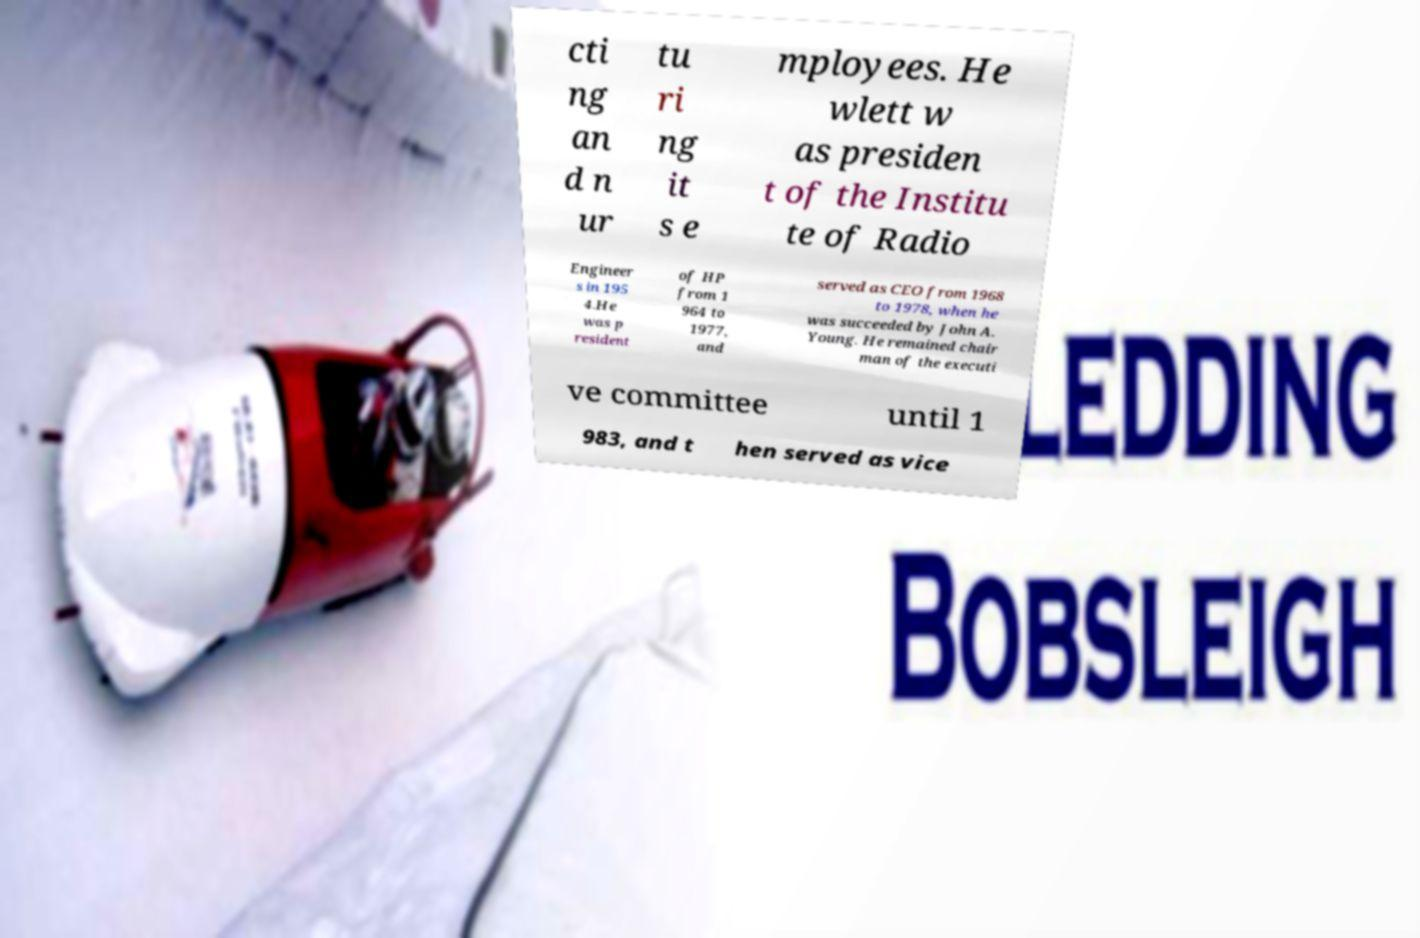Could you assist in decoding the text presented in this image and type it out clearly? cti ng an d n ur tu ri ng it s e mployees. He wlett w as presiden t of the Institu te of Radio Engineer s in 195 4.He was p resident of HP from 1 964 to 1977, and served as CEO from 1968 to 1978, when he was succeeded by John A. Young. He remained chair man of the executi ve committee until 1 983, and t hen served as vice 